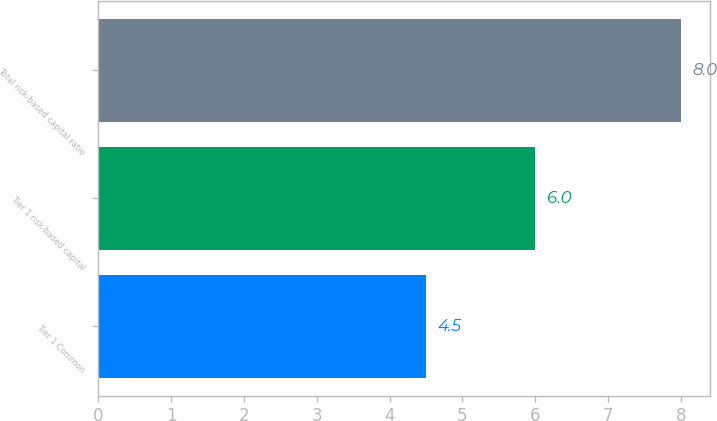<chart> <loc_0><loc_0><loc_500><loc_500><bar_chart><fcel>Tier 1 Common<fcel>Tier 1 risk-based capital<fcel>Total risk-based capital ratio<nl><fcel>4.5<fcel>6<fcel>8<nl></chart> 